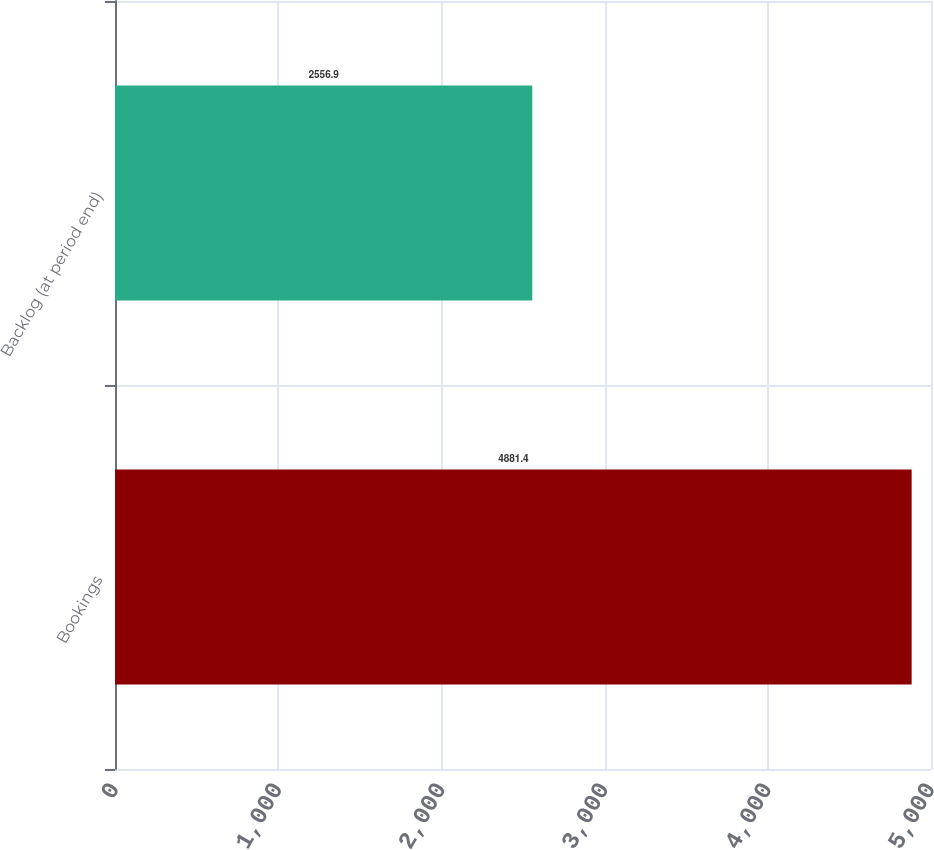Convert chart to OTSL. <chart><loc_0><loc_0><loc_500><loc_500><bar_chart><fcel>Bookings<fcel>Backlog (at period end)<nl><fcel>4881.4<fcel>2556.9<nl></chart> 